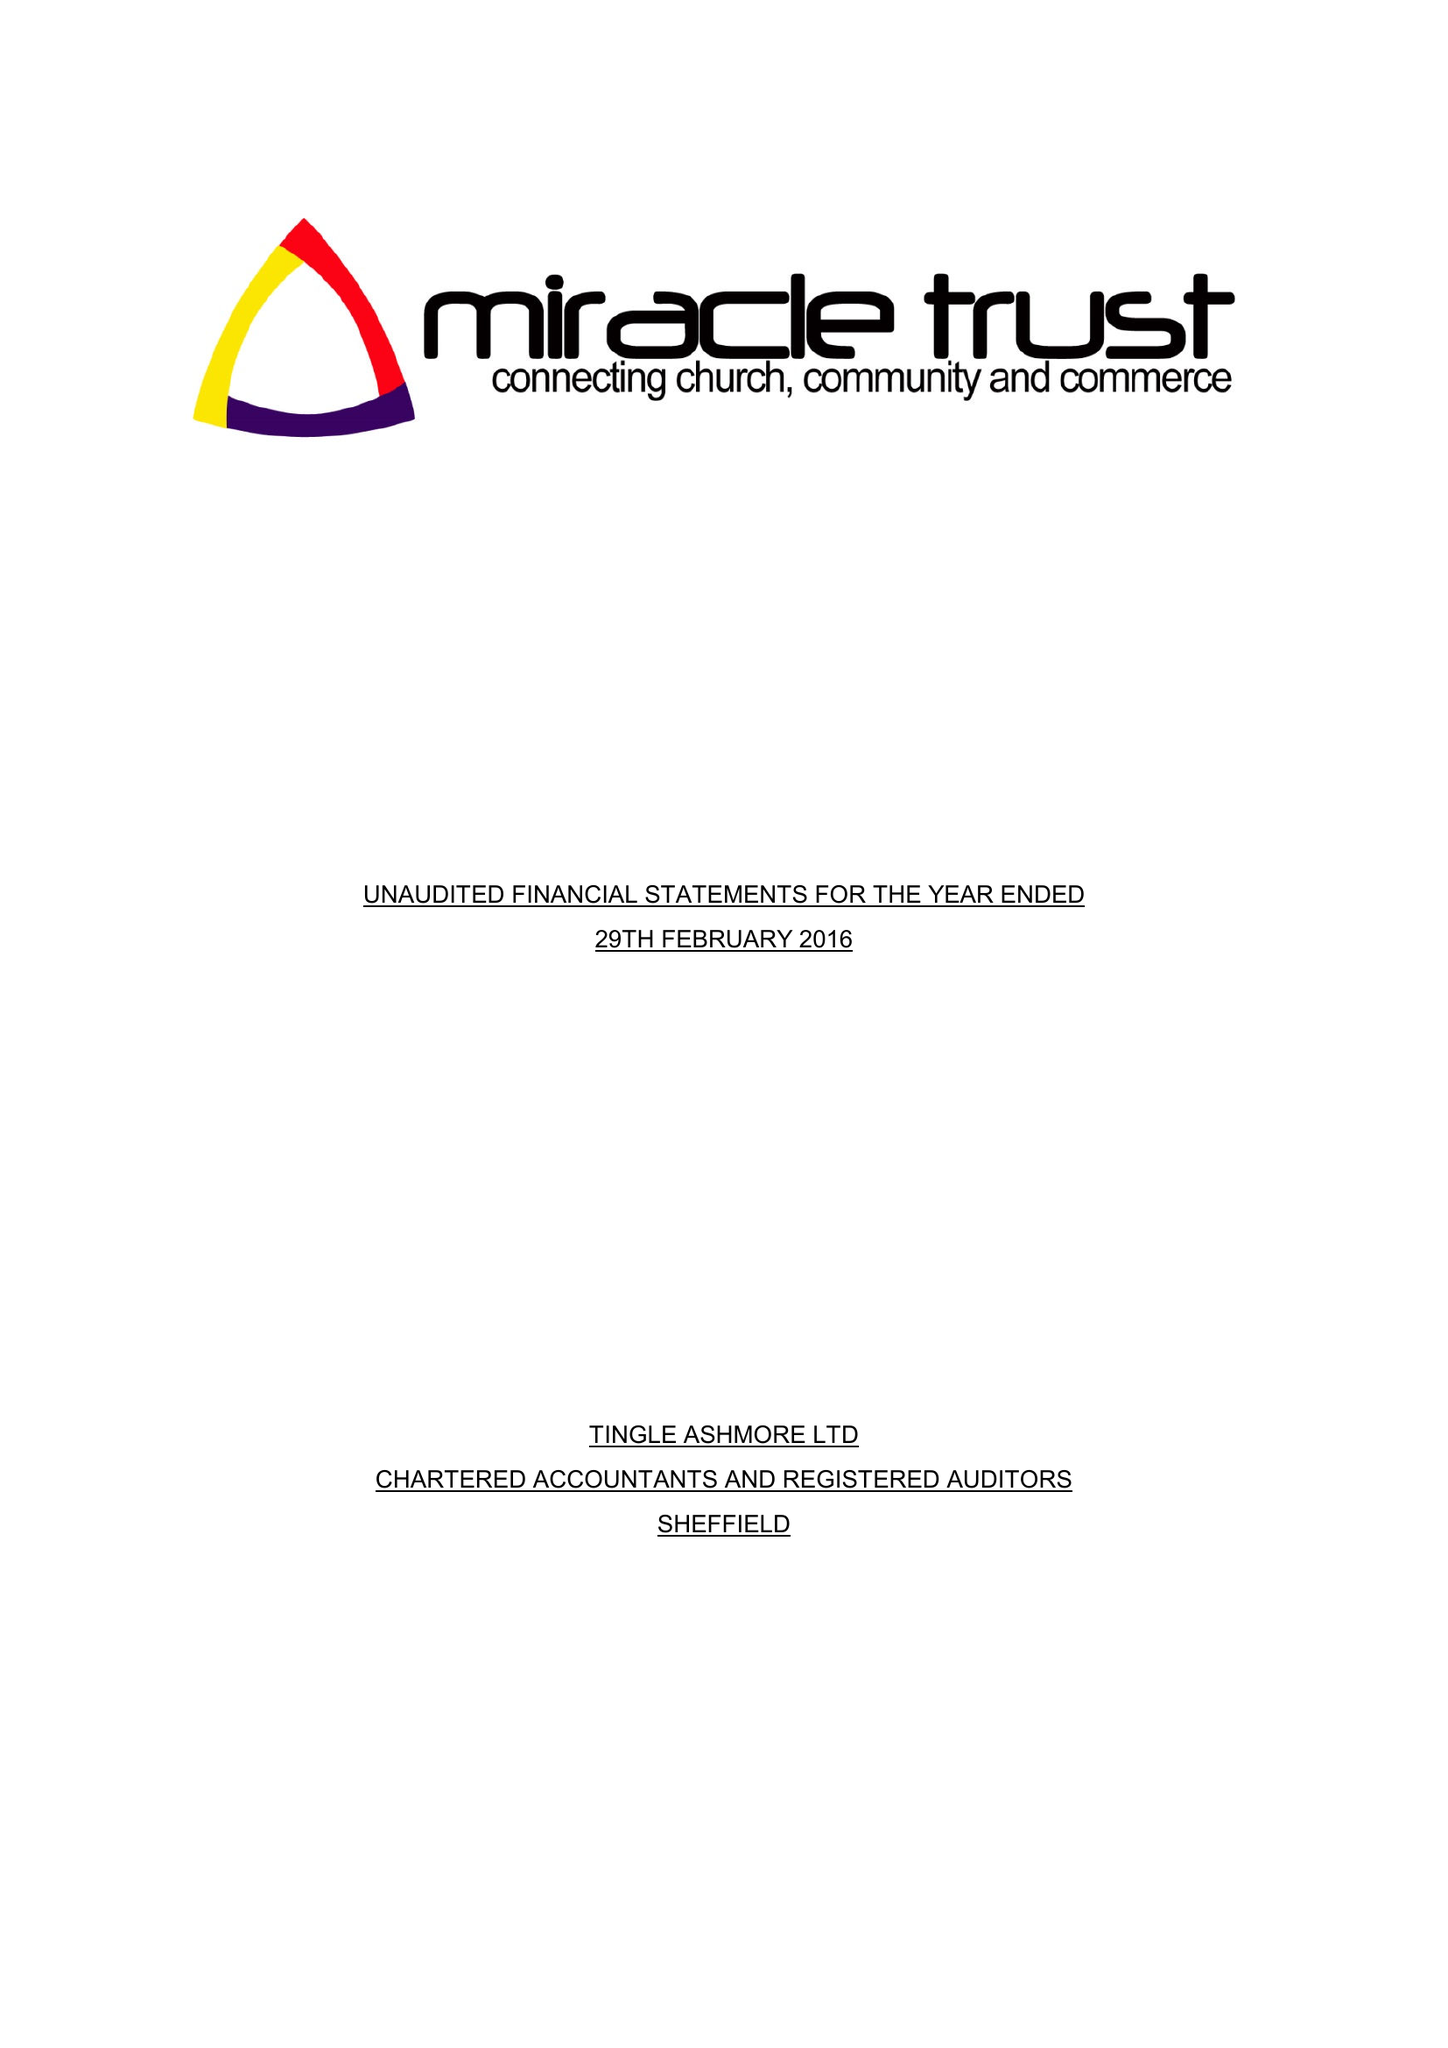What is the value for the address__postcode?
Answer the question using a single word or phrase. S2 2JQ 